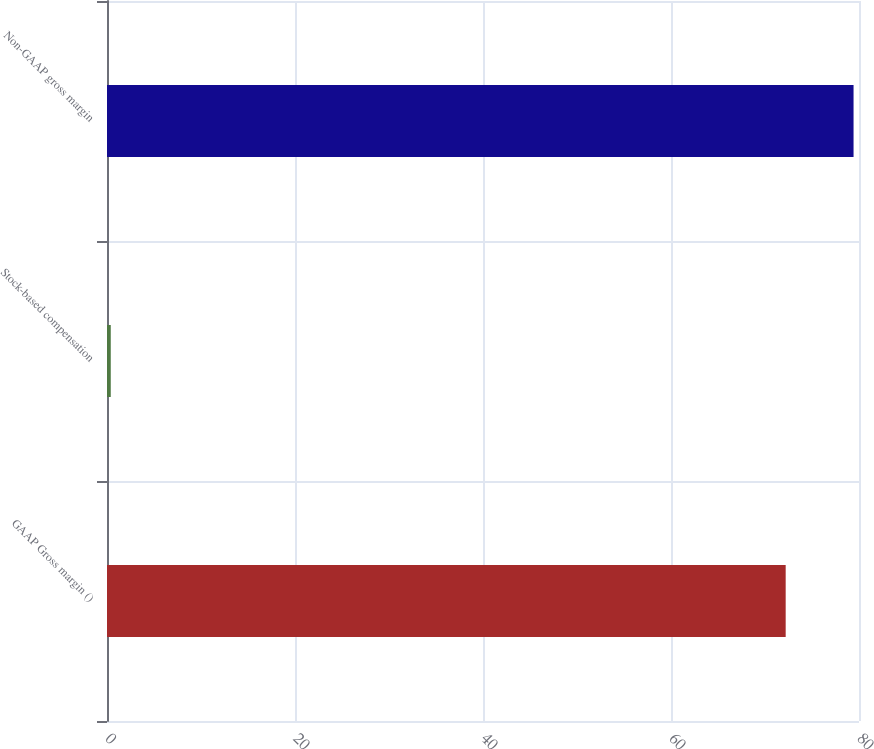Convert chart to OTSL. <chart><loc_0><loc_0><loc_500><loc_500><bar_chart><fcel>GAAP Gross margin ()<fcel>Stock-based compensation<fcel>Non-GAAP gross margin<nl><fcel>72.2<fcel>0.4<fcel>79.42<nl></chart> 